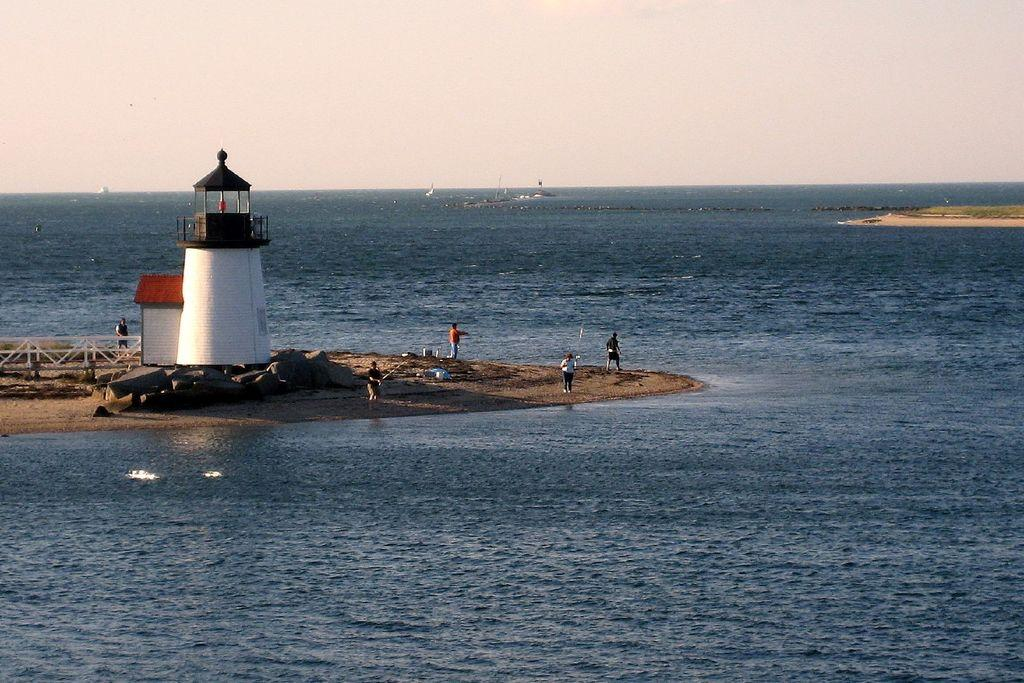What can be seen on the ground in the image? There are people on the ground in the image. What structure is present in the image? There is a lighthouse in the image. What type of barrier is visible in the image? There is a fence in the image. What natural element is visible in the image? There is water visible in the image. How would you describe the sky in the background of the image? The sky in the background is plain. Can you see a mitten being used by someone in the image? There is no mitten present in the image. What type of pan is being used by the people in the image? There is no pan visible in the image. 